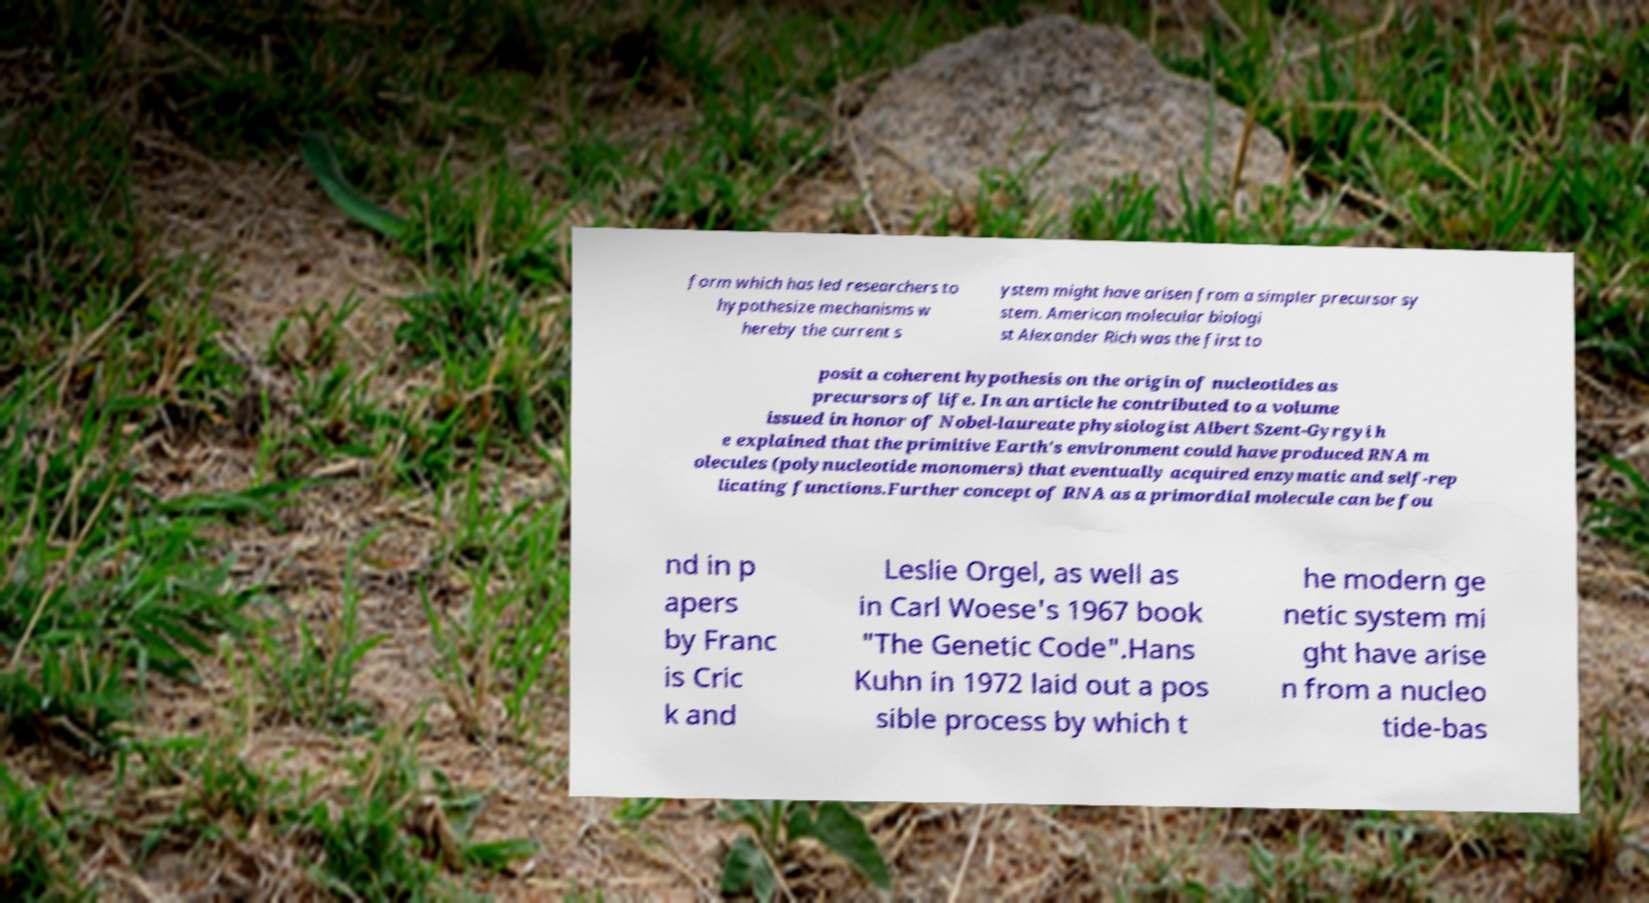Could you extract and type out the text from this image? form which has led researchers to hypothesize mechanisms w hereby the current s ystem might have arisen from a simpler precursor sy stem. American molecular biologi st Alexander Rich was the first to posit a coherent hypothesis on the origin of nucleotides as precursors of life. In an article he contributed to a volume issued in honor of Nobel-laureate physiologist Albert Szent-Gyrgyi h e explained that the primitive Earth's environment could have produced RNA m olecules (polynucleotide monomers) that eventually acquired enzymatic and self-rep licating functions.Further concept of RNA as a primordial molecule can be fou nd in p apers by Franc is Cric k and Leslie Orgel, as well as in Carl Woese's 1967 book "The Genetic Code".Hans Kuhn in 1972 laid out a pos sible process by which t he modern ge netic system mi ght have arise n from a nucleo tide-bas 